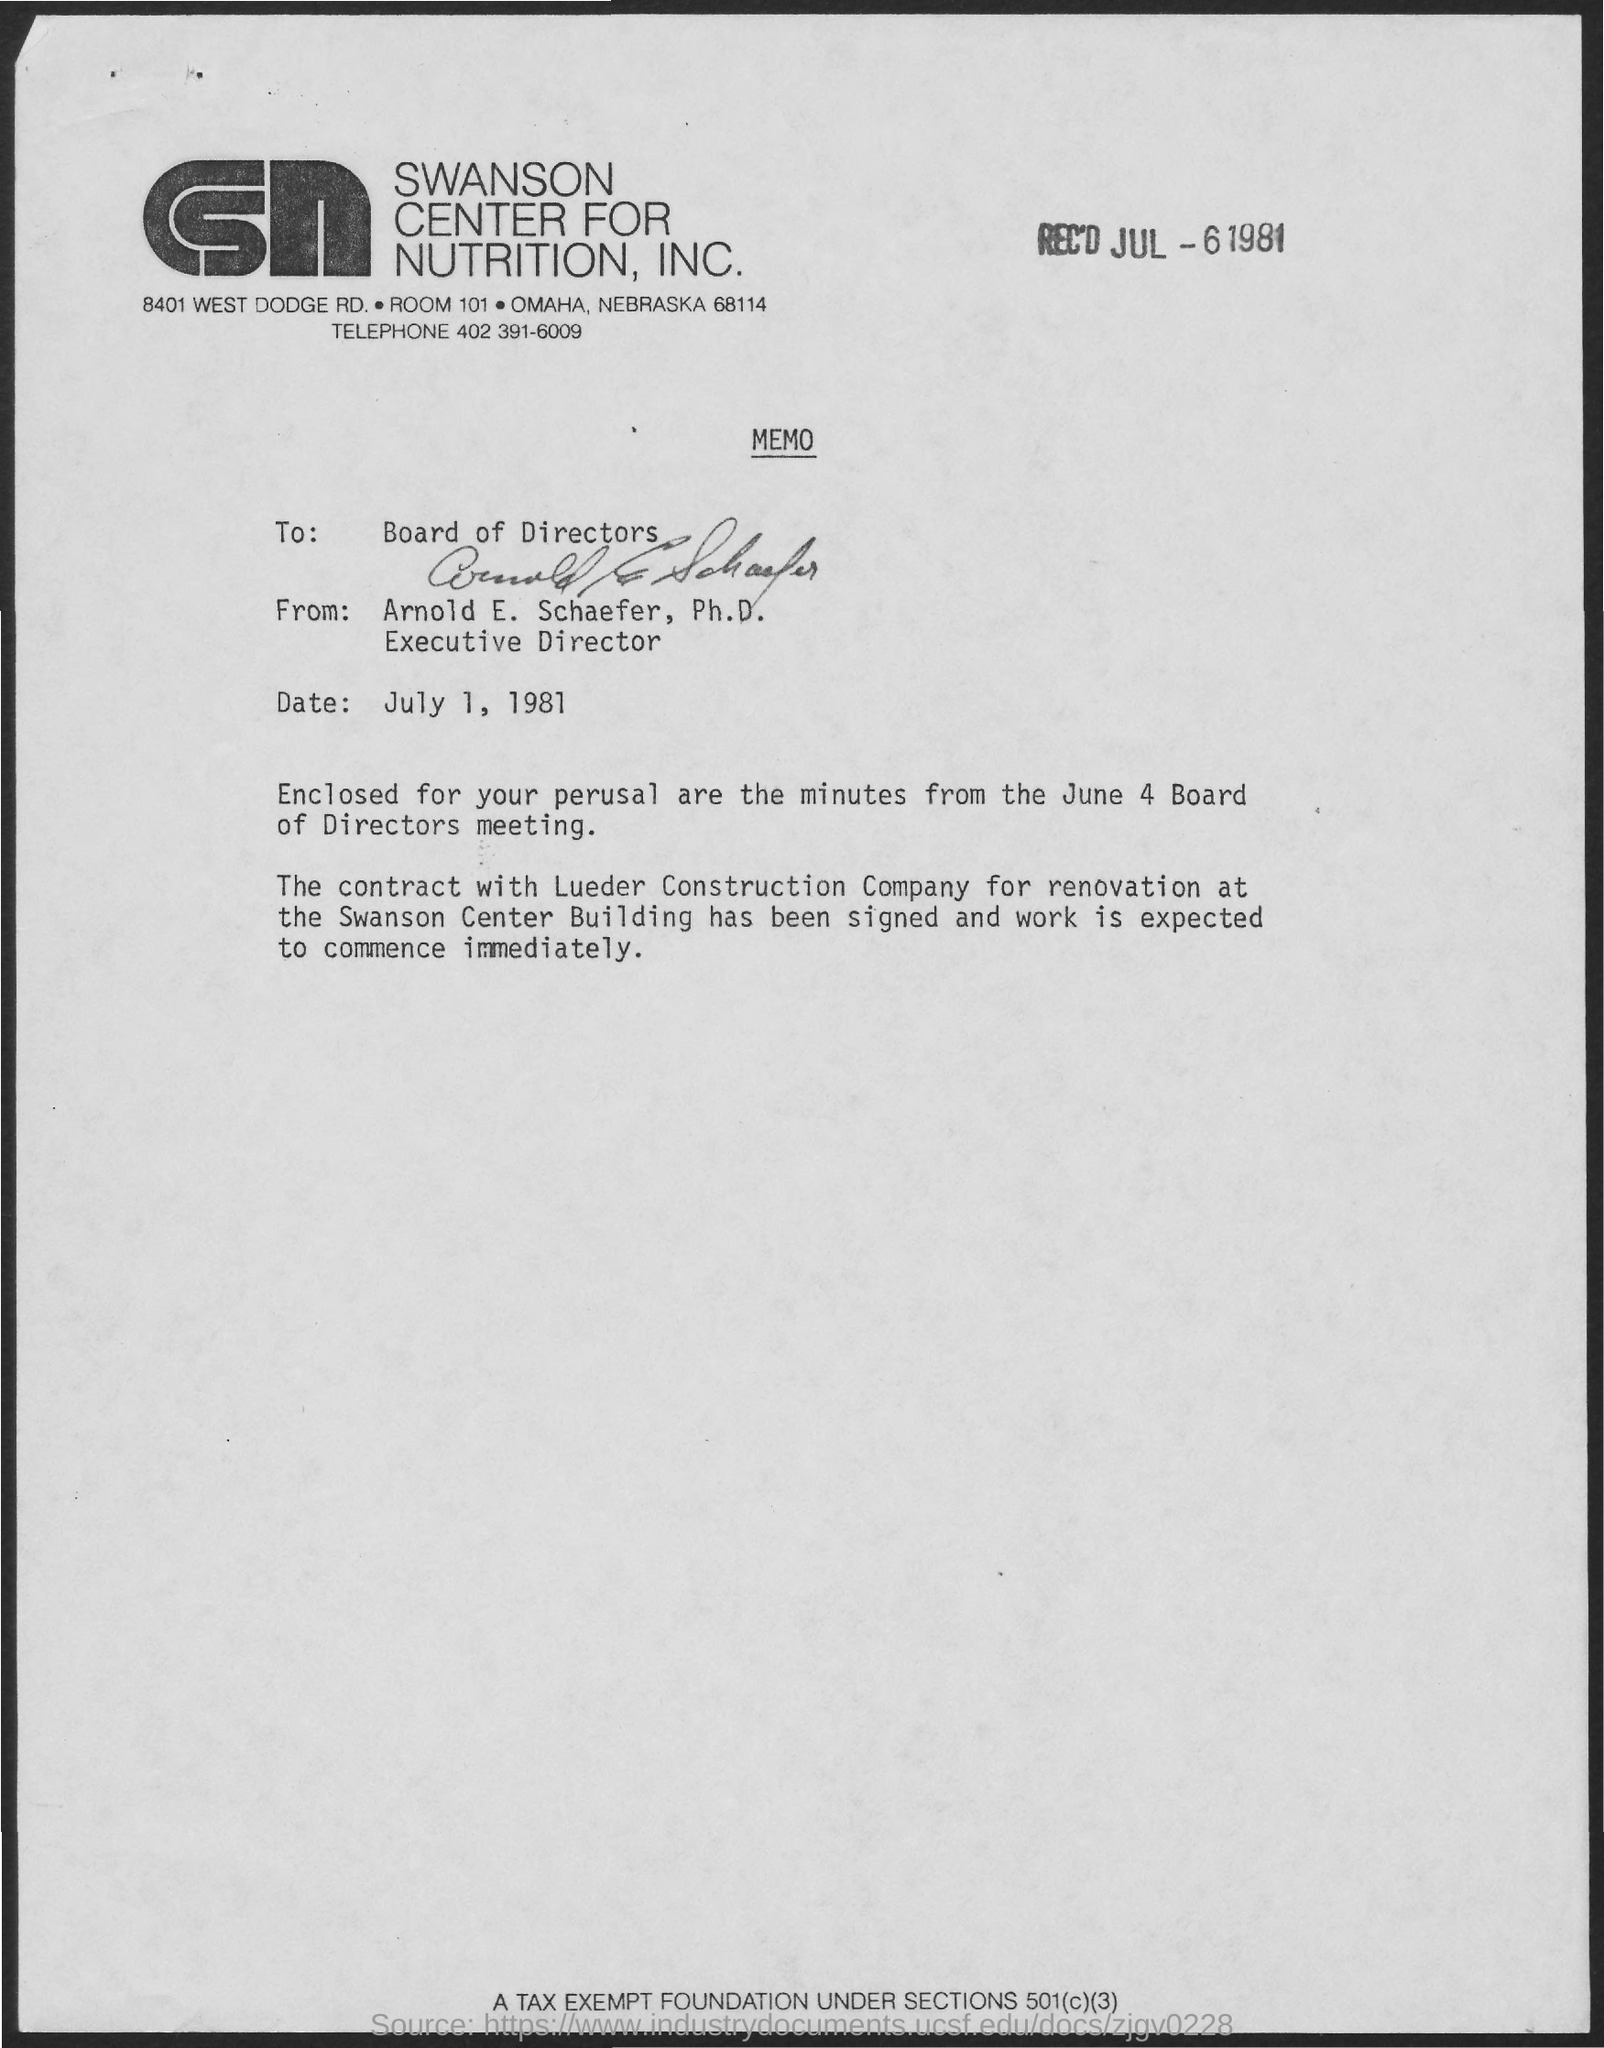Which company's memo is given here?
Make the answer very short. Swanson center for nutrition, inc. Who is the sender of this memo?
Make the answer very short. Arnold E. Schaefer, Ph.D. What is the designation of Arnold E. Schaefer, Ph.D.?
Offer a very short reply. Executive Director. What is the issued date of this memo?
Provide a short and direct response. July 1, 1981. To whom, this memo is addressed?
Offer a very short reply. Board of directors. 